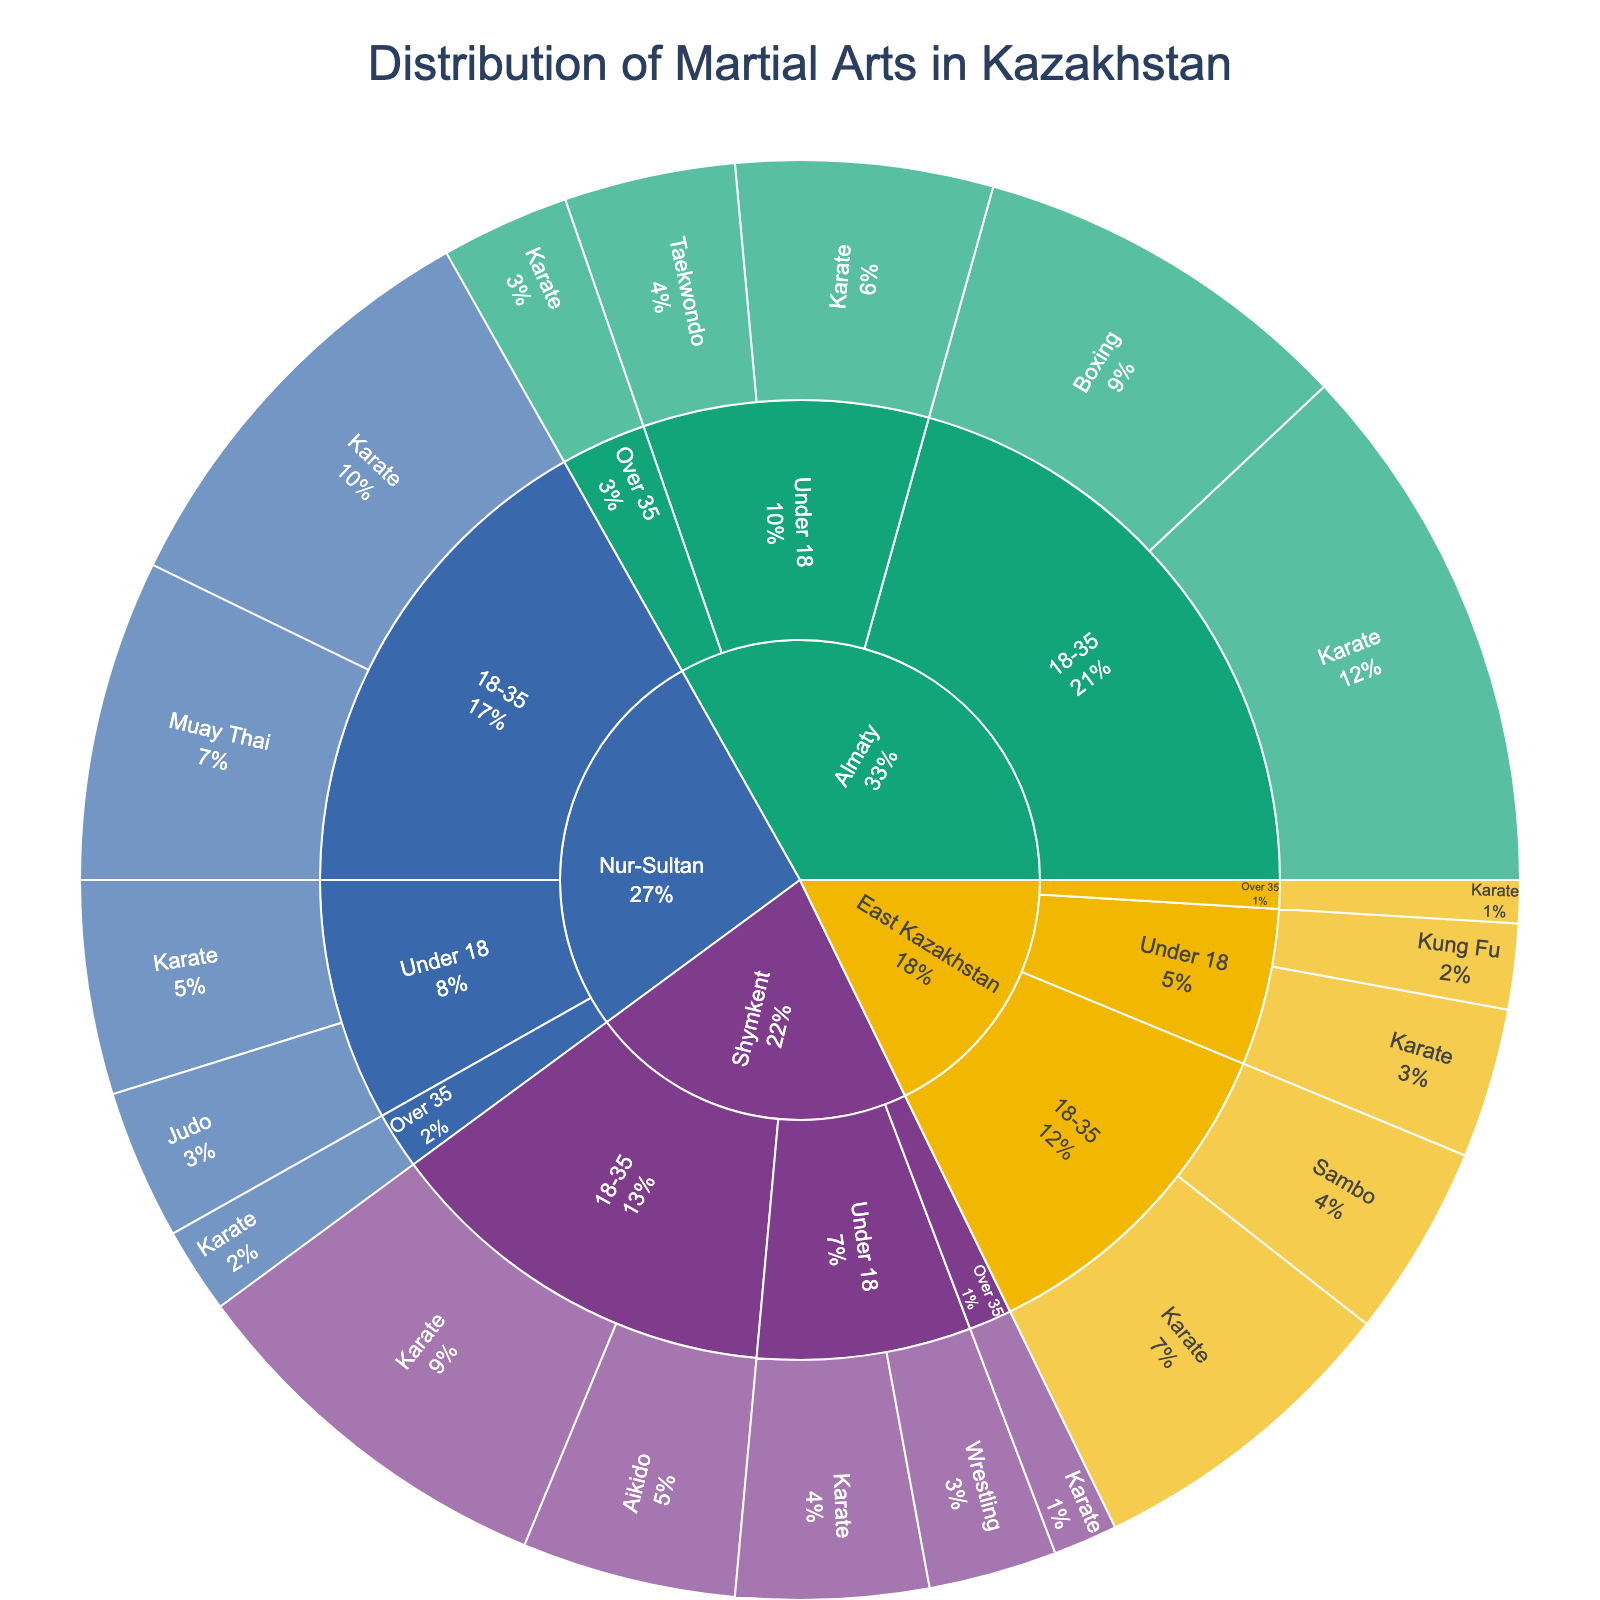what's the title of the plot? The title is usually located at the top of the plot.
Answer: Distribution of Martial Arts in Kazakhstan how many practitioners of wrestling are there in Shymkent under 18? Locate Shymkent in the plot, then find the age group under 18 and the segment for Wrestling.
Answer: 600 which region has the highest number of martial arts practitioners aged 18-35? Compare the sizes of the segments for each region under the age group 18-35. Almaty has the largest segment.
Answer: Almaty how many karate practitioners are there in East Kazakhstan across all age groups? Sum the number of Karate practitioners for the three age groups in East Kazakhstan. 700 (Under 18) + 1500 (18-35) + 200 (Over 35) = 2400
Answer: 2400 which age group has the least number of practitioners in Nur-Sultan? Compare the sizes of the segments for different age groups within Nur-Sultan. Over 35 has the smallest segment.
Answer: Over 35 is karate more popular than taekwondo in Almaty under 18? Compare the sizes of the segments for Karate and Taekwondo in Almaty under the age group under 18. Karate has more practitioners (1200 vs. 800).
Answer: Yes what percentage of practitioners in Shymkent are practicing aikido in the age group 18-35? Locate the segment for Aikido under 18-35 in Shymkent, and check the percentage indicated in the plot.
Answer: 35.71% are there any practitioners of kung fu in regions other than East Kazakhstan? Check all regions for segments labeled Kung Fu. Only East Kazakhstan has Kung Fu practitioners.
Answer: No which martial art has the highest number of total practitioners across all regions and age groups? Sum the number of practitioners for each martial art across all regions and age groups, and compare. Karate has the highest total.
Answer: Karate 